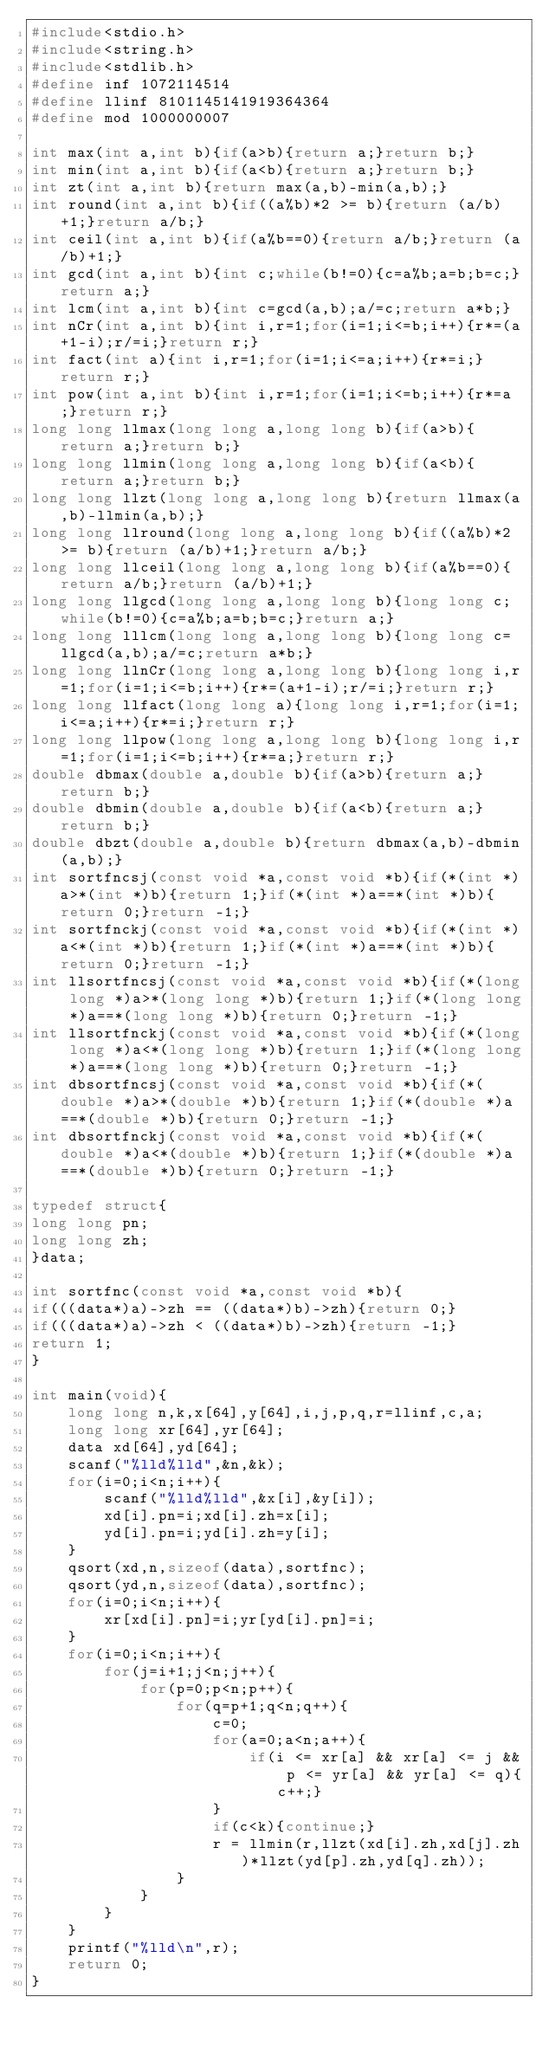<code> <loc_0><loc_0><loc_500><loc_500><_C_>#include<stdio.h>
#include<string.h>
#include<stdlib.h>
#define inf 1072114514
#define llinf 8101145141919364364
#define mod 1000000007

int max(int a,int b){if(a>b){return a;}return b;}
int min(int a,int b){if(a<b){return a;}return b;}
int zt(int a,int b){return max(a,b)-min(a,b);}
int round(int a,int b){if((a%b)*2 >= b){return (a/b)+1;}return a/b;}
int ceil(int a,int b){if(a%b==0){return a/b;}return (a/b)+1;}
int gcd(int a,int b){int c;while(b!=0){c=a%b;a=b;b=c;}return a;}
int lcm(int a,int b){int c=gcd(a,b);a/=c;return a*b;}
int nCr(int a,int b){int i,r=1;for(i=1;i<=b;i++){r*=(a+1-i);r/=i;}return r;}
int fact(int a){int i,r=1;for(i=1;i<=a;i++){r*=i;}return r;}
int pow(int a,int b){int i,r=1;for(i=1;i<=b;i++){r*=a;}return r;}
long long llmax(long long a,long long b){if(a>b){return a;}return b;}
long long llmin(long long a,long long b){if(a<b){return a;}return b;}
long long llzt(long long a,long long b){return llmax(a,b)-llmin(a,b);}
long long llround(long long a,long long b){if((a%b)*2 >= b){return (a/b)+1;}return a/b;}
long long llceil(long long a,long long b){if(a%b==0){return a/b;}return (a/b)+1;}
long long llgcd(long long a,long long b){long long c;while(b!=0){c=a%b;a=b;b=c;}return a;}
long long lllcm(long long a,long long b){long long c=llgcd(a,b);a/=c;return a*b;}
long long llnCr(long long a,long long b){long long i,r=1;for(i=1;i<=b;i++){r*=(a+1-i);r/=i;}return r;}
long long llfact(long long a){long long i,r=1;for(i=1;i<=a;i++){r*=i;}return r;}
long long llpow(long long a,long long b){long long i,r=1;for(i=1;i<=b;i++){r*=a;}return r;}
double dbmax(double a,double b){if(a>b){return a;}return b;}
double dbmin(double a,double b){if(a<b){return a;}return b;}
double dbzt(double a,double b){return dbmax(a,b)-dbmin(a,b);}
int sortfncsj(const void *a,const void *b){if(*(int *)a>*(int *)b){return 1;}if(*(int *)a==*(int *)b){return 0;}return -1;}
int sortfnckj(const void *a,const void *b){if(*(int *)a<*(int *)b){return 1;}if(*(int *)a==*(int *)b){return 0;}return -1;}
int llsortfncsj(const void *a,const void *b){if(*(long long *)a>*(long long *)b){return 1;}if(*(long long *)a==*(long long *)b){return 0;}return -1;}
int llsortfnckj(const void *a,const void *b){if(*(long long *)a<*(long long *)b){return 1;}if(*(long long *)a==*(long long *)b){return 0;}return -1;}
int dbsortfncsj(const void *a,const void *b){if(*(double *)a>*(double *)b){return 1;}if(*(double *)a==*(double *)b){return 0;}return -1;}
int dbsortfnckj(const void *a,const void *b){if(*(double *)a<*(double *)b){return 1;}if(*(double *)a==*(double *)b){return 0;}return -1;}

typedef struct{
long long pn;
long long zh;
}data;
 
int sortfnc(const void *a,const void *b){
if(((data*)a)->zh == ((data*)b)->zh){return 0;}
if(((data*)a)->zh < ((data*)b)->zh){return -1;}
return 1;
}

int main(void){
    long long n,k,x[64],y[64],i,j,p,q,r=llinf,c,a;
    long long xr[64],yr[64];
    data xd[64],yd[64];
    scanf("%lld%lld",&n,&k);
    for(i=0;i<n;i++){
        scanf("%lld%lld",&x[i],&y[i]);
        xd[i].pn=i;xd[i].zh=x[i];
        yd[i].pn=i;yd[i].zh=y[i];
    }
    qsort(xd,n,sizeof(data),sortfnc);
    qsort(yd,n,sizeof(data),sortfnc);
    for(i=0;i<n;i++){
        xr[xd[i].pn]=i;yr[yd[i].pn]=i;
    }
    for(i=0;i<n;i++){
        for(j=i+1;j<n;j++){
            for(p=0;p<n;p++){
                for(q=p+1;q<n;q++){
                    c=0;
                    for(a=0;a<n;a++){
                        if(i <= xr[a] && xr[a] <= j && p <= yr[a] && yr[a] <= q){c++;}
                    }
                    if(c<k){continue;}
                    r = llmin(r,llzt(xd[i].zh,xd[j].zh)*llzt(yd[p].zh,yd[q].zh));
                }
            }
        }
    }
    printf("%lld\n",r);
    return 0;
}</code> 